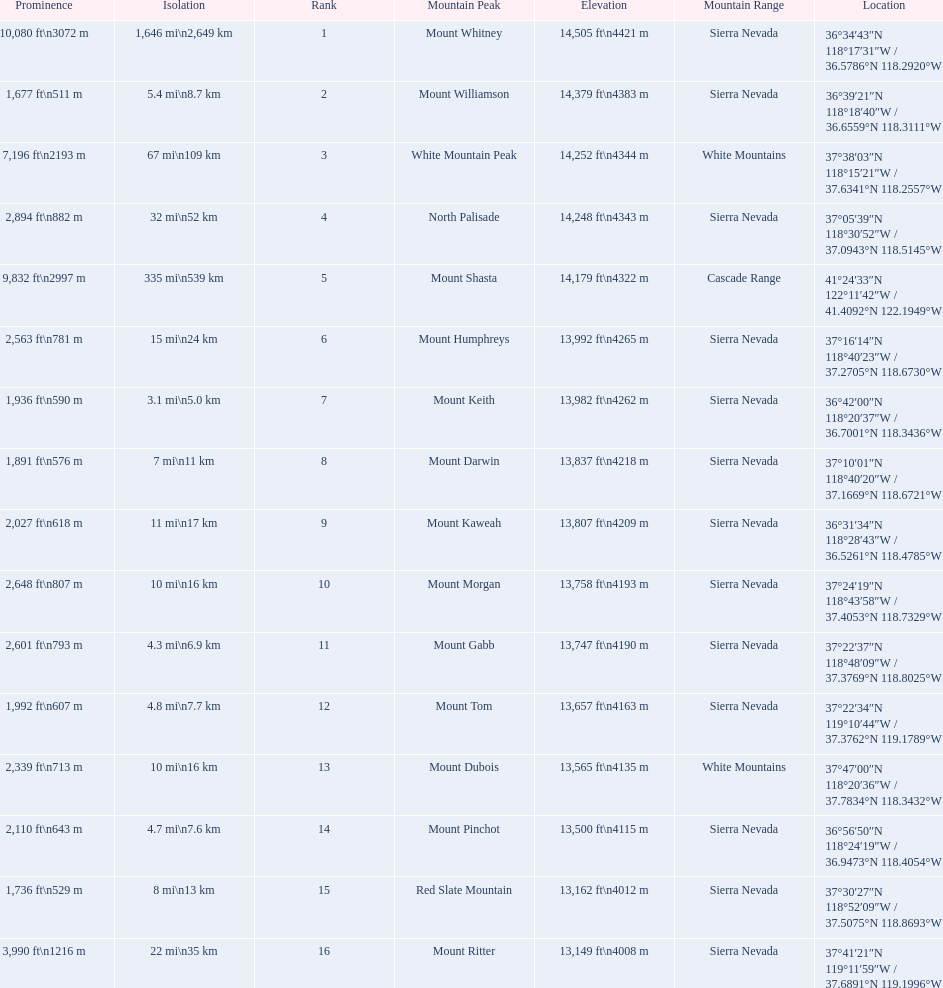Help me parse the entirety of this table. {'header': ['Prominence', 'Isolation', 'Rank', 'Mountain Peak', 'Elevation', 'Mountain Range', 'Location'], 'rows': [['10,080\xa0ft\\n3072\xa0m', '1,646\xa0mi\\n2,649\xa0km', '1', 'Mount Whitney', '14,505\xa0ft\\n4421\xa0m', 'Sierra Nevada', '36°34′43″N 118°17′31″W\ufeff / \ufeff36.5786°N 118.2920°W'], ['1,677\xa0ft\\n511\xa0m', '5.4\xa0mi\\n8.7\xa0km', '2', 'Mount Williamson', '14,379\xa0ft\\n4383\xa0m', 'Sierra Nevada', '36°39′21″N 118°18′40″W\ufeff / \ufeff36.6559°N 118.3111°W'], ['7,196\xa0ft\\n2193\xa0m', '67\xa0mi\\n109\xa0km', '3', 'White Mountain Peak', '14,252\xa0ft\\n4344\xa0m', 'White Mountains', '37°38′03″N 118°15′21″W\ufeff / \ufeff37.6341°N 118.2557°W'], ['2,894\xa0ft\\n882\xa0m', '32\xa0mi\\n52\xa0km', '4', 'North Palisade', '14,248\xa0ft\\n4343\xa0m', 'Sierra Nevada', '37°05′39″N 118°30′52″W\ufeff / \ufeff37.0943°N 118.5145°W'], ['9,832\xa0ft\\n2997\xa0m', '335\xa0mi\\n539\xa0km', '5', 'Mount Shasta', '14,179\xa0ft\\n4322\xa0m', 'Cascade Range', '41°24′33″N 122°11′42″W\ufeff / \ufeff41.4092°N 122.1949°W'], ['2,563\xa0ft\\n781\xa0m', '15\xa0mi\\n24\xa0km', '6', 'Mount Humphreys', '13,992\xa0ft\\n4265\xa0m', 'Sierra Nevada', '37°16′14″N 118°40′23″W\ufeff / \ufeff37.2705°N 118.6730°W'], ['1,936\xa0ft\\n590\xa0m', '3.1\xa0mi\\n5.0\xa0km', '7', 'Mount Keith', '13,982\xa0ft\\n4262\xa0m', 'Sierra Nevada', '36°42′00″N 118°20′37″W\ufeff / \ufeff36.7001°N 118.3436°W'], ['1,891\xa0ft\\n576\xa0m', '7\xa0mi\\n11\xa0km', '8', 'Mount Darwin', '13,837\xa0ft\\n4218\xa0m', 'Sierra Nevada', '37°10′01″N 118°40′20″W\ufeff / \ufeff37.1669°N 118.6721°W'], ['2,027\xa0ft\\n618\xa0m', '11\xa0mi\\n17\xa0km', '9', 'Mount Kaweah', '13,807\xa0ft\\n4209\xa0m', 'Sierra Nevada', '36°31′34″N 118°28′43″W\ufeff / \ufeff36.5261°N 118.4785°W'], ['2,648\xa0ft\\n807\xa0m', '10\xa0mi\\n16\xa0km', '10', 'Mount Morgan', '13,758\xa0ft\\n4193\xa0m', 'Sierra Nevada', '37°24′19″N 118°43′58″W\ufeff / \ufeff37.4053°N 118.7329°W'], ['2,601\xa0ft\\n793\xa0m', '4.3\xa0mi\\n6.9\xa0km', '11', 'Mount Gabb', '13,747\xa0ft\\n4190\xa0m', 'Sierra Nevada', '37°22′37″N 118°48′09″W\ufeff / \ufeff37.3769°N 118.8025°W'], ['1,992\xa0ft\\n607\xa0m', '4.8\xa0mi\\n7.7\xa0km', '12', 'Mount Tom', '13,657\xa0ft\\n4163\xa0m', 'Sierra Nevada', '37°22′34″N 119°10′44″W\ufeff / \ufeff37.3762°N 119.1789°W'], ['2,339\xa0ft\\n713\xa0m', '10\xa0mi\\n16\xa0km', '13', 'Mount Dubois', '13,565\xa0ft\\n4135\xa0m', 'White Mountains', '37°47′00″N 118°20′36″W\ufeff / \ufeff37.7834°N 118.3432°W'], ['2,110\xa0ft\\n643\xa0m', '4.7\xa0mi\\n7.6\xa0km', '14', 'Mount Pinchot', '13,500\xa0ft\\n4115\xa0m', 'Sierra Nevada', '36°56′50″N 118°24′19″W\ufeff / \ufeff36.9473°N 118.4054°W'], ['1,736\xa0ft\\n529\xa0m', '8\xa0mi\\n13\xa0km', '15', 'Red Slate Mountain', '13,162\xa0ft\\n4012\xa0m', 'Sierra Nevada', '37°30′27″N 118°52′09″W\ufeff / \ufeff37.5075°N 118.8693°W'], ['3,990\xa0ft\\n1216\xa0m', '22\xa0mi\\n35\xa0km', '16', 'Mount Ritter', '13,149\xa0ft\\n4008\xa0m', 'Sierra Nevada', '37°41′21″N 119°11′59″W\ufeff / \ufeff37.6891°N 119.1996°W']]} In feet, what is the difference between the tallest peak and the 9th tallest peak in california? 698 ft. 